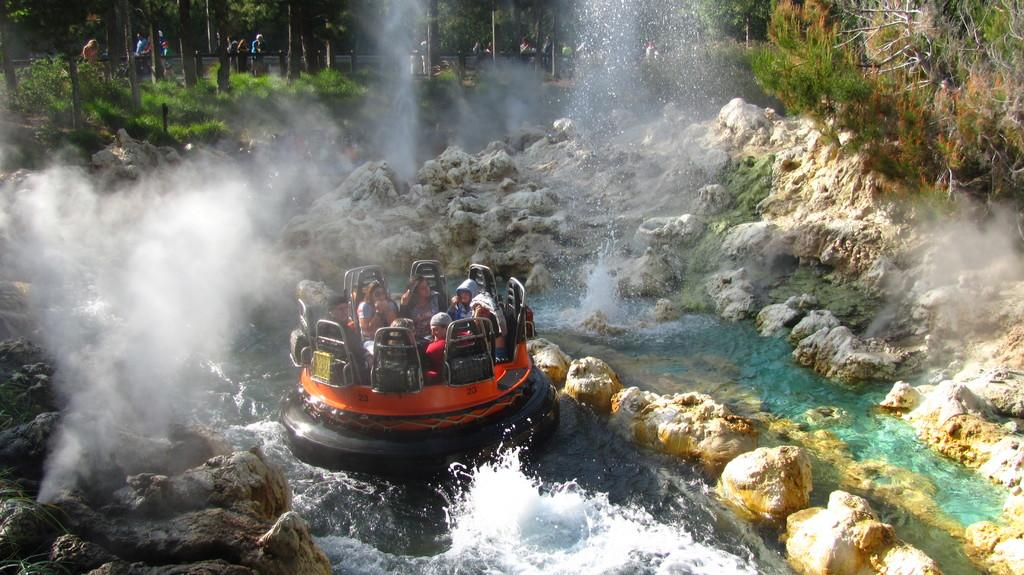What are the people in the image doing? There is a group of people sitting in the image. What type of natural elements can be seen in the image? Rocks and water are present in the image. Can you describe the background of the image? There are people and trees in the background of the image. What type of skate is being used by the people in the image? There is no skate present in the image; the people are sitting. Can you see a heart-shaped object in the image? There is no heart-shaped object present in the image. 